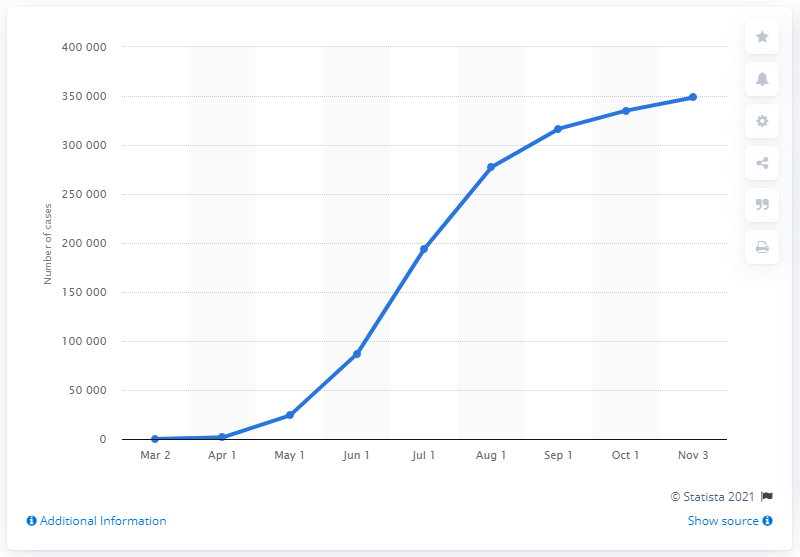Draw attention to some important aspects in this diagram. As of November 3, 2020, there were 348,510 confirmed cases of coronavirus in Saudi Arabia. 